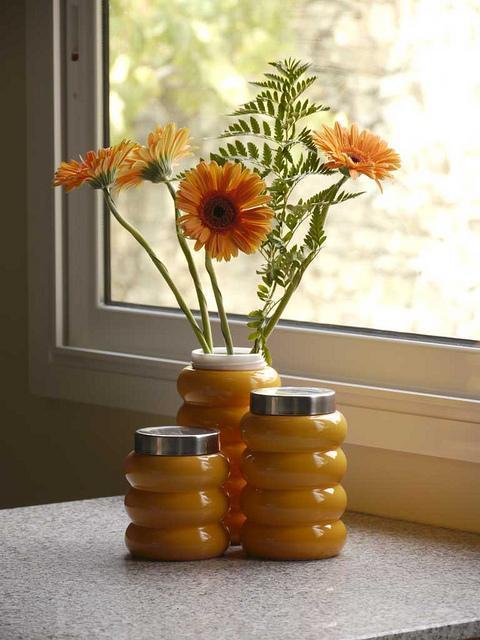How many containers are on the counter?
Give a very brief answer. 3. How many vases are in the picture?
Give a very brief answer. 3. How many vases are in the photo?
Give a very brief answer. 3. 